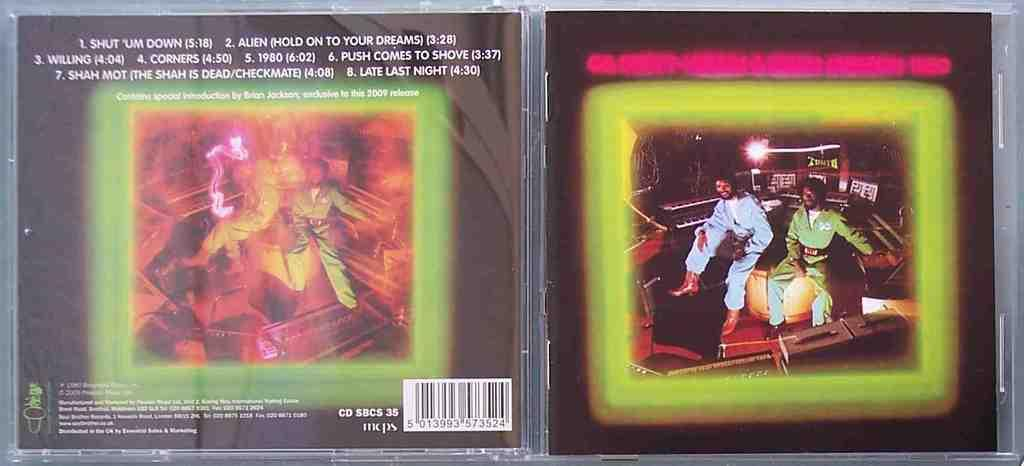<image>
Summarize the visual content of the image. A CD cover lists various songs, including Shut 'um Down. 